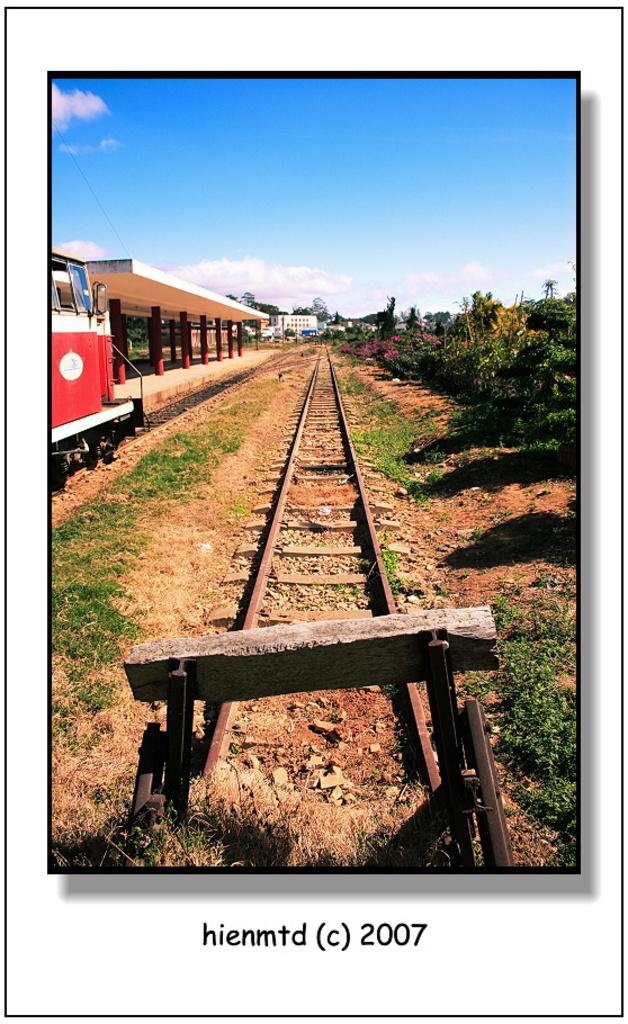What year was the photo taken?
Make the answer very short. 2007. 